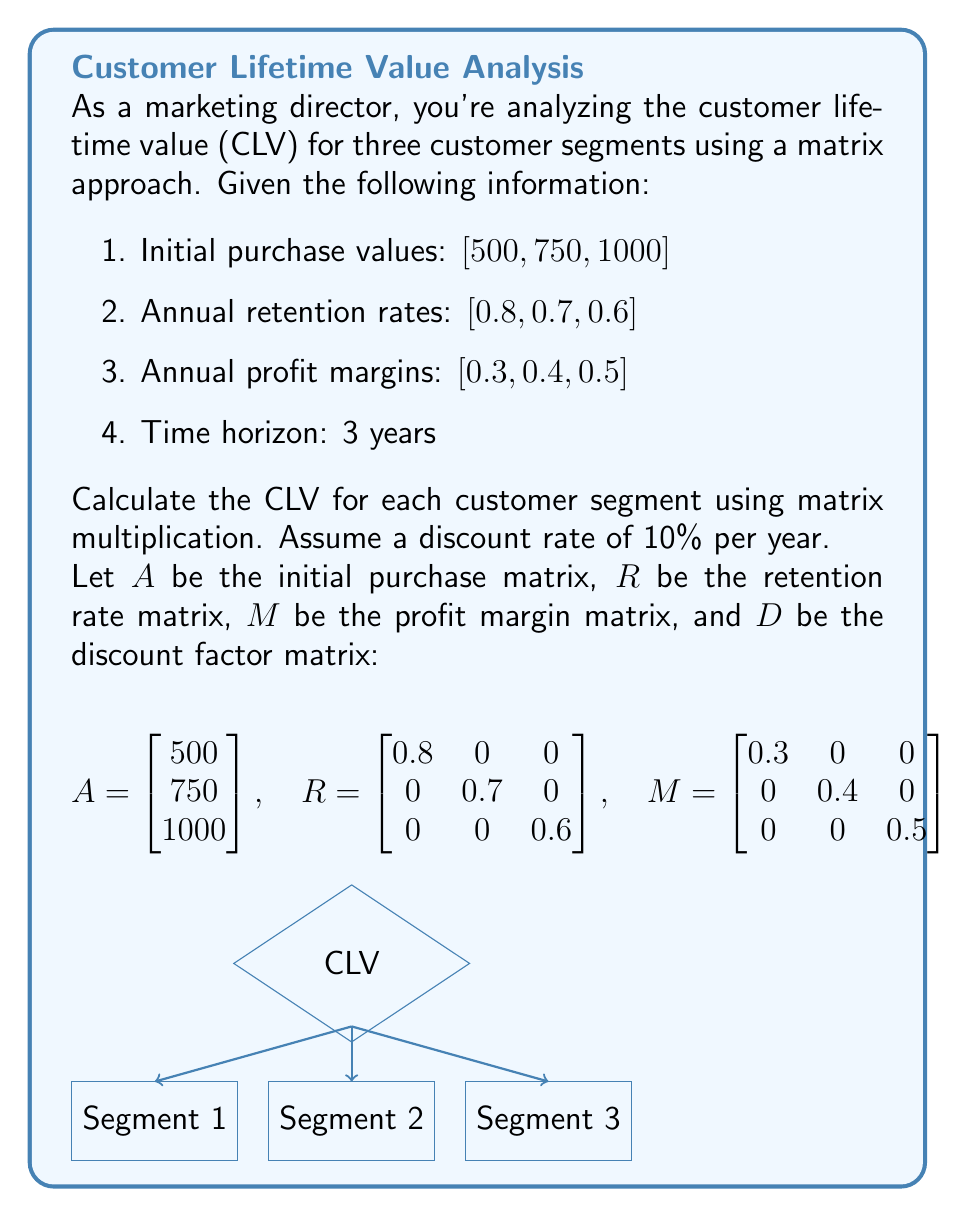Provide a solution to this math problem. To calculate the CLV for each customer segment using matrices, we'll follow these steps:

1. Calculate the revenue matrix for each year:
   $$Revenue_1 = A$$
   $$Revenue_2 = R \times A$$
   $$Revenue_3 = R^2 \times A$$

2. Calculate the profit matrix for each year:
   $$Profit_1 = M \times Revenue_1$$
   $$Profit_2 = M \times Revenue_2$$
   $$Profit_3 = M \times Revenue_3$$

3. Combine the profits into a single matrix:
   $$Profits = [Profit_1 \quad Profit_2 \quad Profit_3]$$

4. Multiply the combined profits by the discount factor matrix:
   $$CLV = Profits \times D$$

Let's perform the calculations:

1. Revenue matrices:
   $$Revenue_1 = \begin{bmatrix} 500 \\ 750 \\ 1000 \end{bmatrix}$$
   $$Revenue_2 = \begin{bmatrix} 0.8 & 0 & 0 \\ 0 & 0.7 & 0 \\ 0 & 0 & 0.6 \end{bmatrix} \times \begin{bmatrix} 500 \\ 750 \\ 1000 \end{bmatrix} = \begin{bmatrix} 400 \\ 525 \\ 600 \end{bmatrix}$$
   $$Revenue_3 = \begin{bmatrix} 0.8 & 0 & 0 \\ 0 & 0.7 & 0 \\ 0 & 0 & 0.6 \end{bmatrix}^2 \times \begin{bmatrix} 500 \\ 750 \\ 1000 \end{bmatrix} = \begin{bmatrix} 320 \\ 367.5 \\ 360 \end{bmatrix}$$

2. Profit matrices:
   $$Profit_1 = \begin{bmatrix} 0.3 & 0 & 0 \\ 0 & 0.4 & 0 \\ 0 & 0 & 0.5 \end{bmatrix} \times \begin{bmatrix} 500 \\ 750 \\ 1000 \end{bmatrix} = \begin{bmatrix} 150 \\ 300 \\ 500 \end{bmatrix}$$
   $$Profit_2 = \begin{bmatrix} 0.3 & 0 & 0 \\ 0 & 0.4 & 0 \\ 0 & 0 & 0.5 \end{bmatrix} \times \begin{bmatrix} 400 \\ 525 \\ 600 \end{bmatrix} = \begin{bmatrix} 120 \\ 210 \\ 300 \end{bmatrix}$$
   $$Profit_3 = \begin{bmatrix} 0.3 & 0 & 0 \\ 0 & 0.4 & 0 \\ 0 & 0 & 0.5 \end{bmatrix} \times \begin{bmatrix} 320 \\ 367.5 \\ 360 \end{bmatrix} = \begin{bmatrix} 96 \\ 147 \\ 180 \end{bmatrix}$$

3. Combined profits:
   $$Profits = \begin{bmatrix} 150 & 120 & 96 \\ 300 & 210 & 147 \\ 500 & 300 & 180 \end{bmatrix}$$

4. CLV calculation:
   $$CLV = \begin{bmatrix} 150 & 120 & 96 \\ 300 & 210 & 147 \\ 500 & 300 & 180 \end{bmatrix} \times \begin{bmatrix} 1 \\ 0.909 \\ 0.826 \end{bmatrix} = \begin{bmatrix} 339.70 \\ 604.13 \\ 889.30 \end{bmatrix}$$

Therefore, the CLV for each customer segment is:
- Segment 1: $339.70
- Segment 2: $604.13
- Segment 3: $889.30
Answer: $\begin{bmatrix} 339.70 \\ 604.13 \\ 889.30 \end{bmatrix}$ 